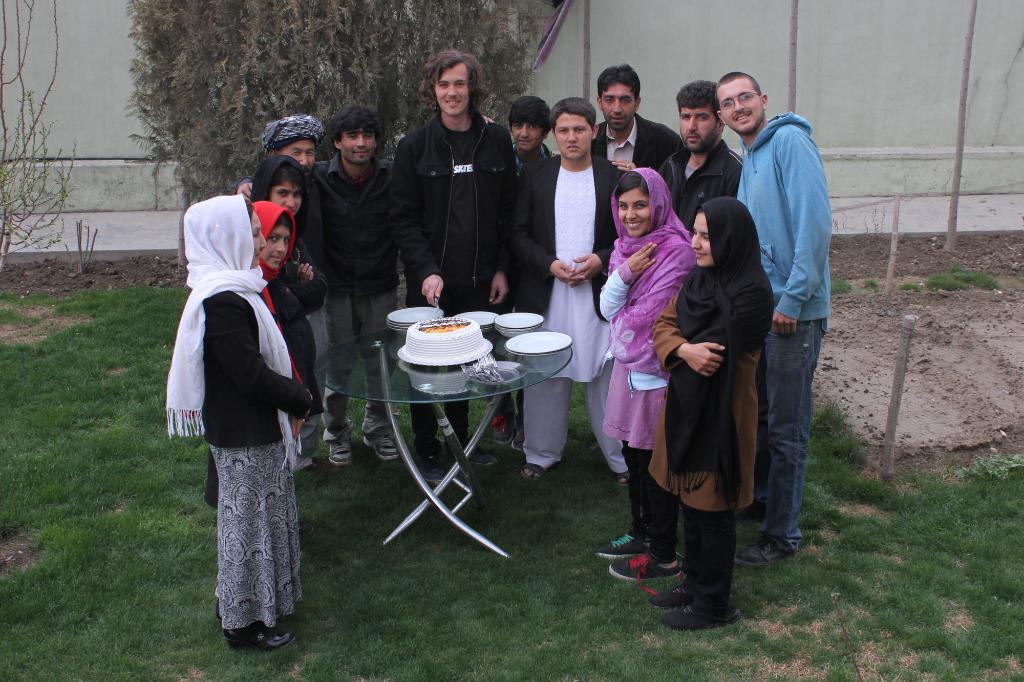What can be seen in the image involving people? There are persons standing in the image. What is on the table in the image? There is a cake on the table, along with plates. What is the background of the image like? There is a wall visible in the background, with trees and grass present. What type of comfort can be seen being provided by the ice in the image? There is no ice present in the image, so comfort cannot be provided by ice. 